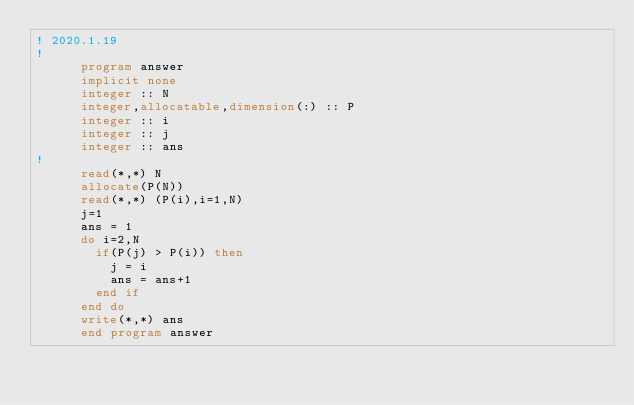Convert code to text. <code><loc_0><loc_0><loc_500><loc_500><_FORTRAN_>! 2020.1.19
!
      program answer
      implicit none
      integer :: N
      integer,allocatable,dimension(:) :: P
      integer :: i
      integer :: j
      integer :: ans
!
      read(*,*) N
      allocate(P(N))
      read(*,*) (P(i),i=1,N)
      j=1
      ans = 1
      do i=2,N
        if(P(j) > P(i)) then
          j = i
          ans = ans+1
        end if
      end do
      write(*,*) ans
      end program answer</code> 